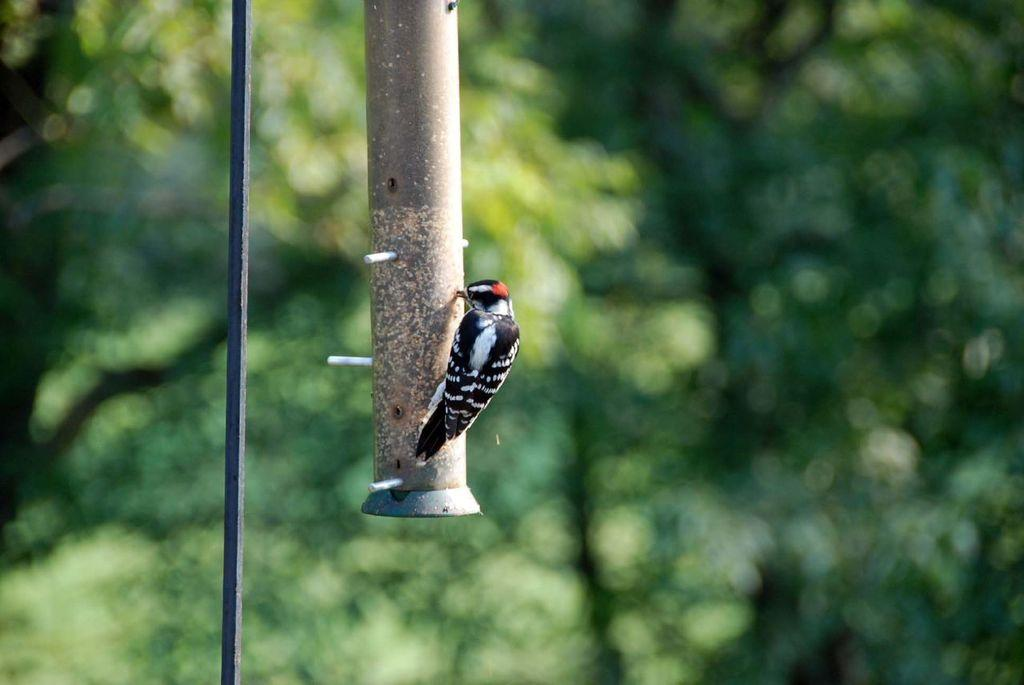What is the main subject of the image? There is a bird in the center of the image. What can be seen in the background of the image? There are trees in the background of the image. What type of protest is taking place in the image? There is no protest present in the image; it features a bird and trees. What kind of silk material can be seen in the image? There is no silk material present in the image. 